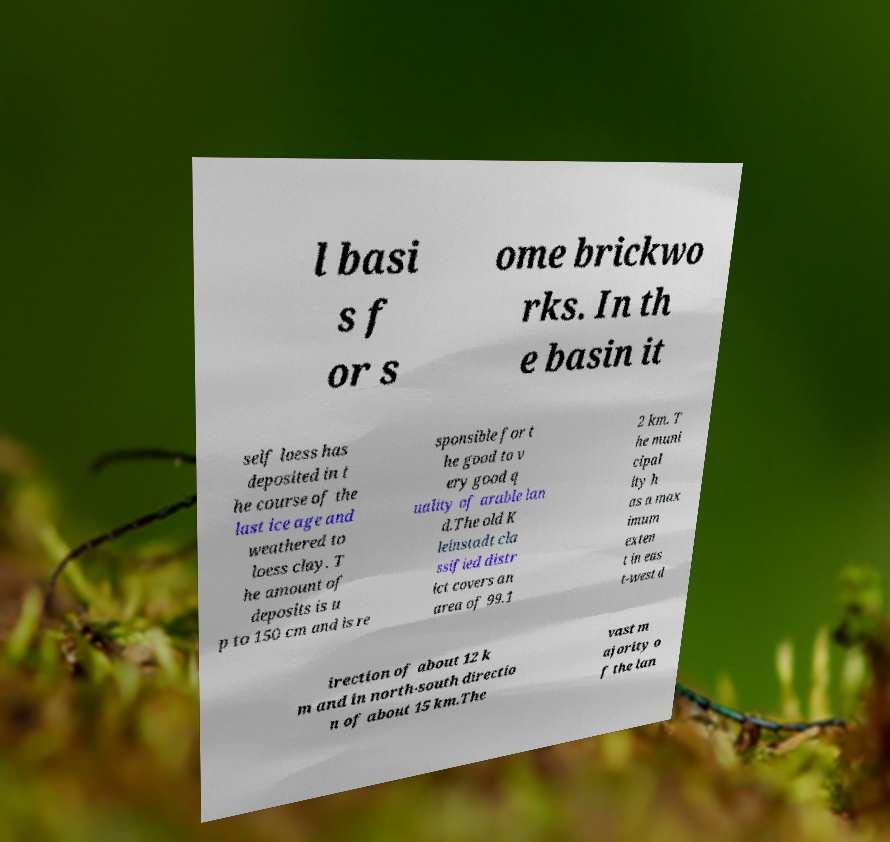Can you accurately transcribe the text from the provided image for me? l basi s f or s ome brickwo rks. In th e basin it self loess has deposited in t he course of the last ice age and weathered to loess clay. T he amount of deposits is u p to 150 cm and is re sponsible for t he good to v ery good q uality of arable lan d.The old K leinstadt cla ssified distr ict covers an area of 99.1 2 km. T he muni cipal ity h as a max imum exten t in eas t-west d irection of about 12 k m and in north-south directio n of about 15 km.The vast m ajority o f the lan 